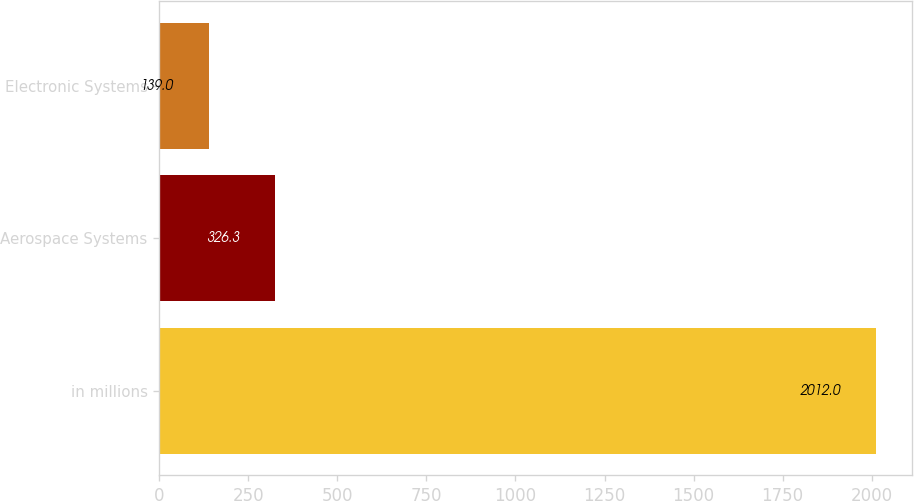<chart> <loc_0><loc_0><loc_500><loc_500><bar_chart><fcel>in millions<fcel>Aerospace Systems<fcel>Electronic Systems<nl><fcel>2012<fcel>326.3<fcel>139<nl></chart> 